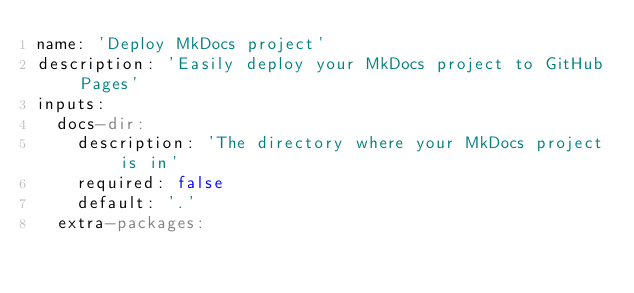Convert code to text. <code><loc_0><loc_0><loc_500><loc_500><_YAML_>name: 'Deploy MkDocs project'
description: 'Easily deploy your MkDocs project to GitHub Pages'
inputs:
  docs-dir:
    description: 'The directory where your MkDocs project is in'
    required: false
    default: '.'
  extra-packages:</code> 